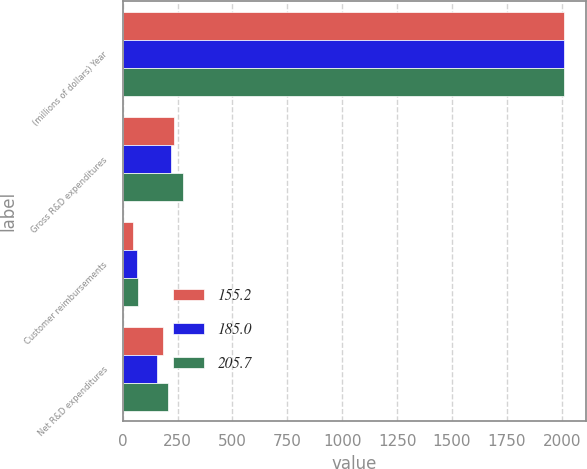Convert chart. <chart><loc_0><loc_0><loc_500><loc_500><stacked_bar_chart><ecel><fcel>(millions of dollars) Year<fcel>Gross R&D expenditures<fcel>Customer reimbursements<fcel>Net R&D expenditures<nl><fcel>155.2<fcel>2010<fcel>233.2<fcel>48.2<fcel>185<nl><fcel>185<fcel>2009<fcel>219<fcel>63.8<fcel>155.2<nl><fcel>205.7<fcel>2008<fcel>273.4<fcel>67.7<fcel>205.7<nl></chart> 